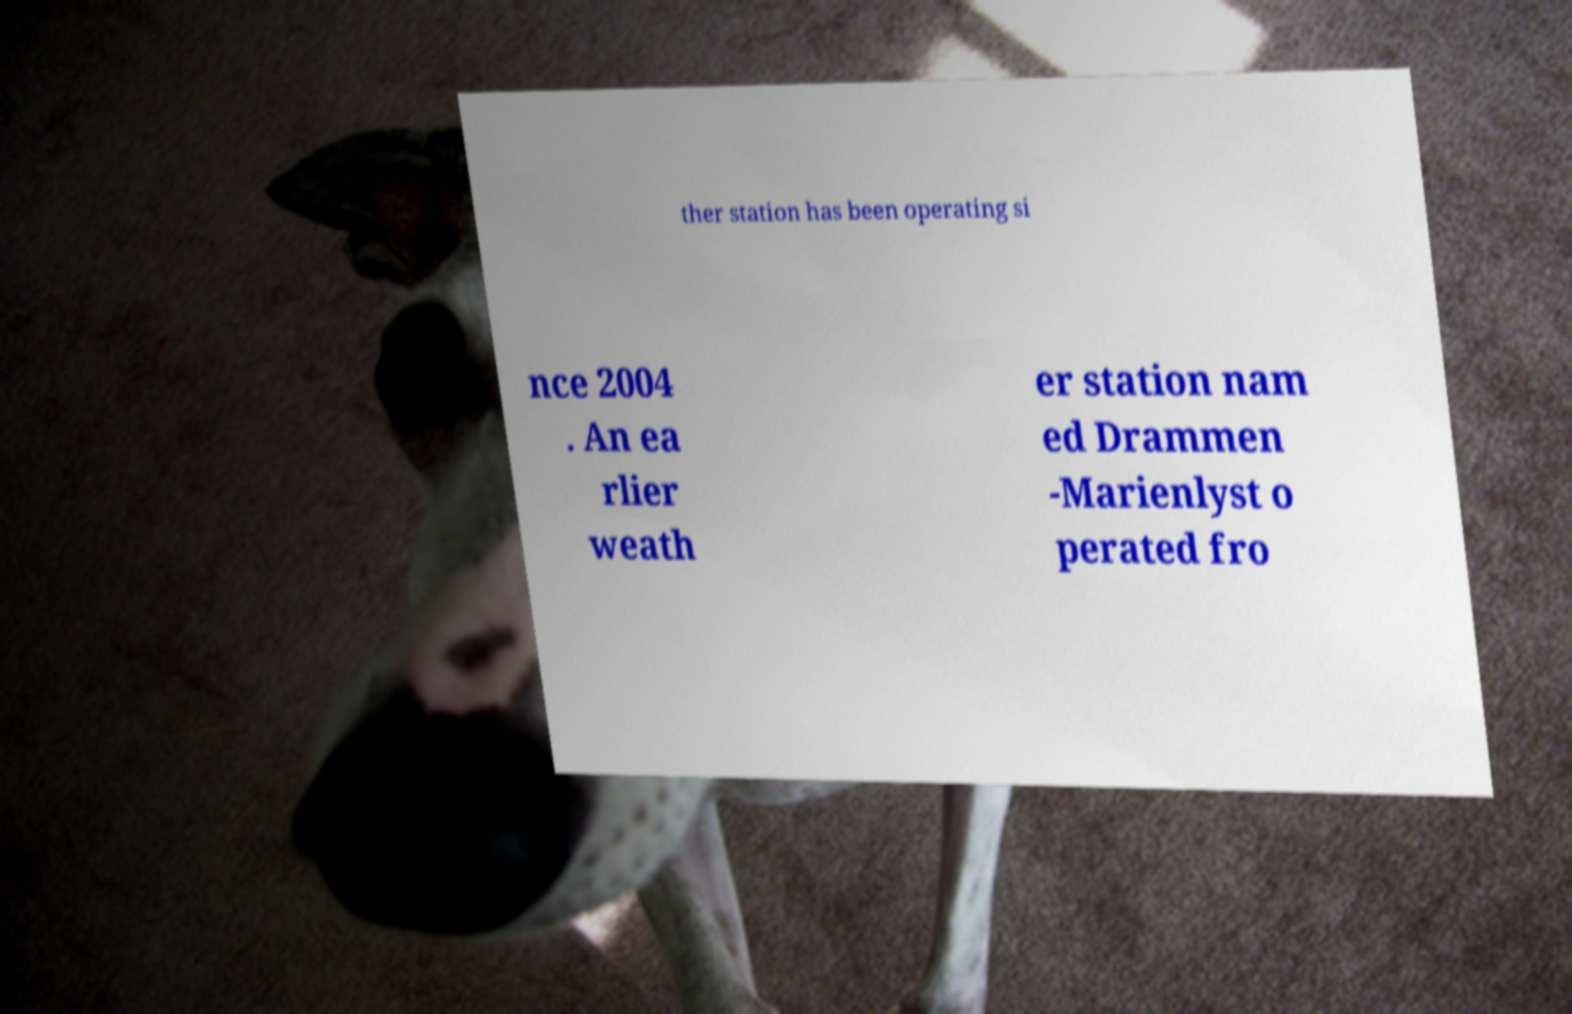For documentation purposes, I need the text within this image transcribed. Could you provide that? ther station has been operating si nce 2004 . An ea rlier weath er station nam ed Drammen -Marienlyst o perated fro 